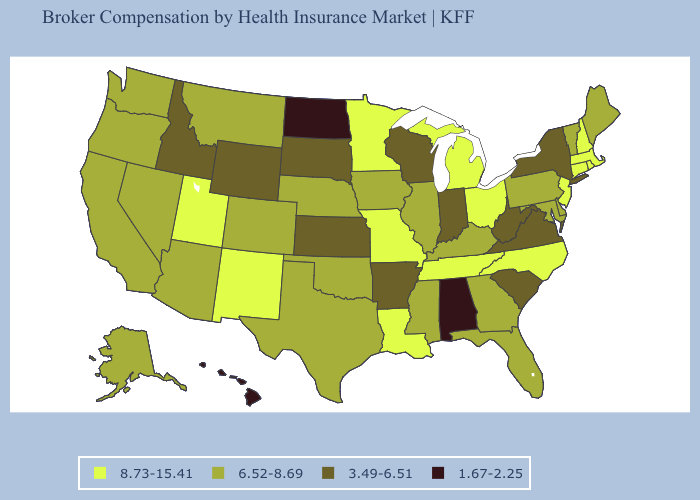What is the value of Indiana?
Concise answer only. 3.49-6.51. Does Vermont have the highest value in the Northeast?
Concise answer only. No. Name the states that have a value in the range 1.67-2.25?
Short answer required. Alabama, Hawaii, North Dakota. Does Alabama have the lowest value in the USA?
Be succinct. Yes. What is the value of California?
Concise answer only. 6.52-8.69. Does Rhode Island have the highest value in the USA?
Quick response, please. Yes. Name the states that have a value in the range 3.49-6.51?
Quick response, please. Arkansas, Idaho, Indiana, Kansas, New York, South Carolina, South Dakota, Virginia, West Virginia, Wisconsin, Wyoming. Does Rhode Island have the lowest value in the Northeast?
Quick response, please. No. What is the value of Vermont?
Be succinct. 6.52-8.69. Name the states that have a value in the range 6.52-8.69?
Short answer required. Alaska, Arizona, California, Colorado, Delaware, Florida, Georgia, Illinois, Iowa, Kentucky, Maine, Maryland, Mississippi, Montana, Nebraska, Nevada, Oklahoma, Oregon, Pennsylvania, Texas, Vermont, Washington. Name the states that have a value in the range 6.52-8.69?
Write a very short answer. Alaska, Arizona, California, Colorado, Delaware, Florida, Georgia, Illinois, Iowa, Kentucky, Maine, Maryland, Mississippi, Montana, Nebraska, Nevada, Oklahoma, Oregon, Pennsylvania, Texas, Vermont, Washington. Which states have the lowest value in the Northeast?
Quick response, please. New York. What is the value of Georgia?
Answer briefly. 6.52-8.69. What is the value of Arizona?
Short answer required. 6.52-8.69. 